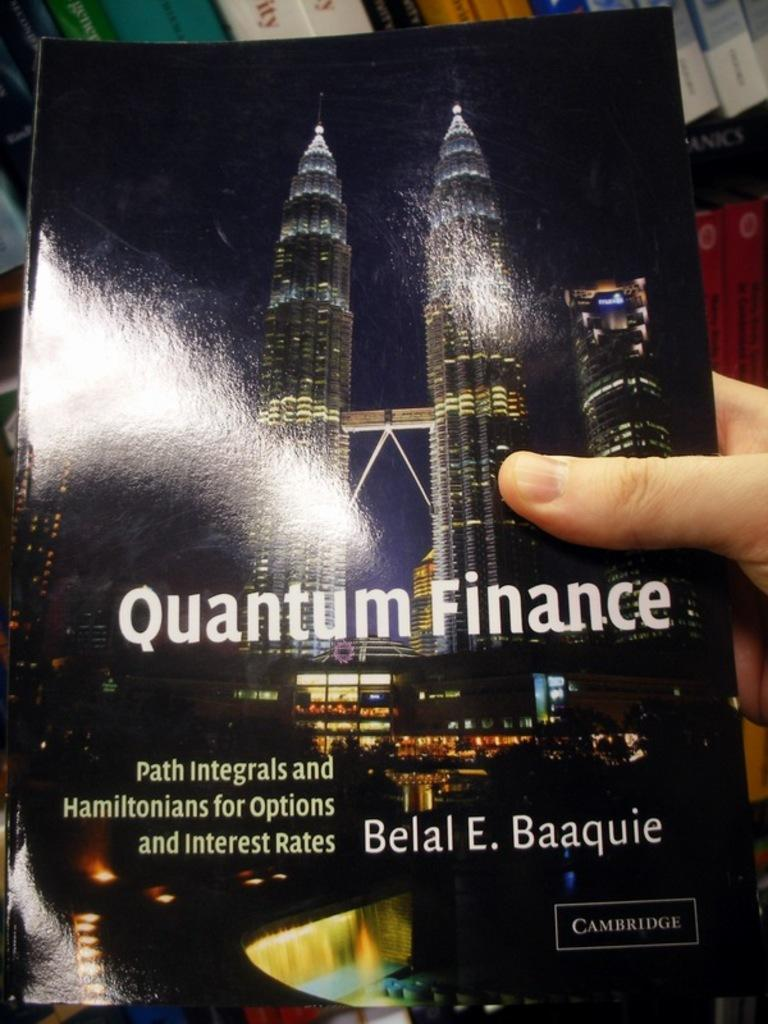Provide a one-sentence caption for the provided image. Someone is holding a book called Quantum Finance. 